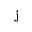<formula> <loc_0><loc_0><loc_500><loc_500>{ j }</formula> 